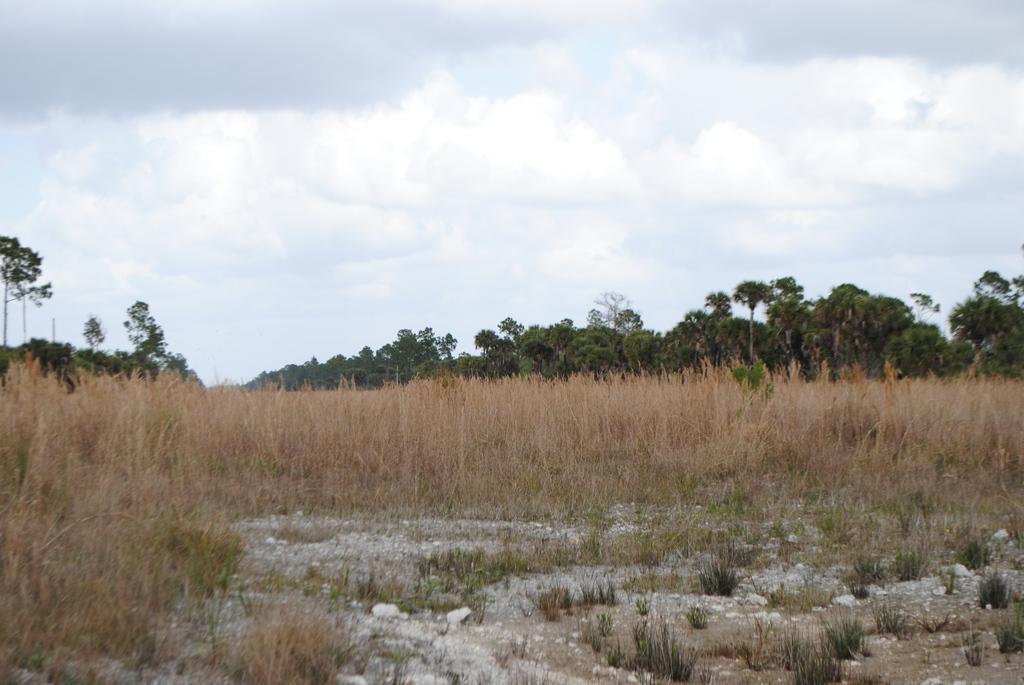How would you summarize this image in a sentence or two? In this image we can see dry grass. In the background of the image there are trees, sky and clouds. 